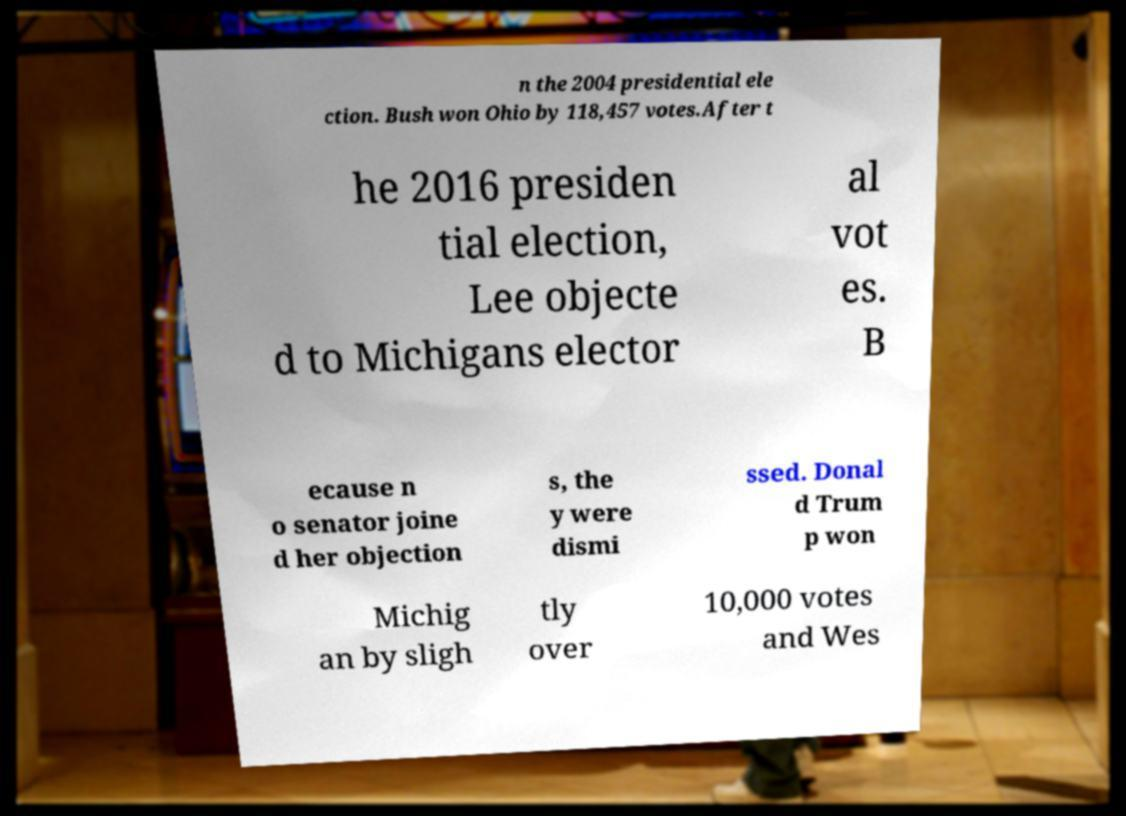Could you extract and type out the text from this image? n the 2004 presidential ele ction. Bush won Ohio by 118,457 votes.After t he 2016 presiden tial election, Lee objecte d to Michigans elector al vot es. B ecause n o senator joine d her objection s, the y were dismi ssed. Donal d Trum p won Michig an by sligh tly over 10,000 votes and Wes 